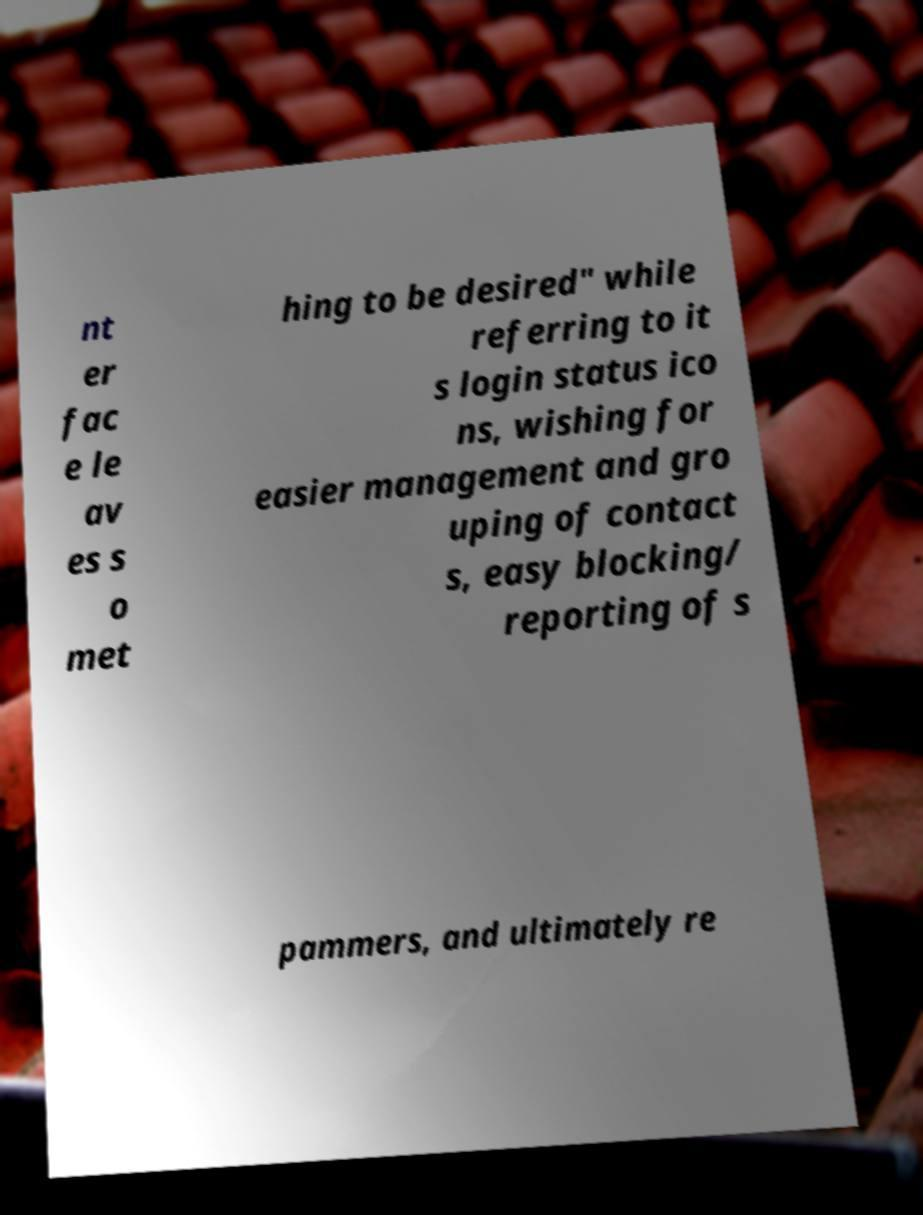For documentation purposes, I need the text within this image transcribed. Could you provide that? nt er fac e le av es s o met hing to be desired" while referring to it s login status ico ns, wishing for easier management and gro uping of contact s, easy blocking/ reporting of s pammers, and ultimately re 